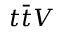Convert formula to latex. <formula><loc_0><loc_0><loc_500><loc_500>t \bar { t } V</formula> 